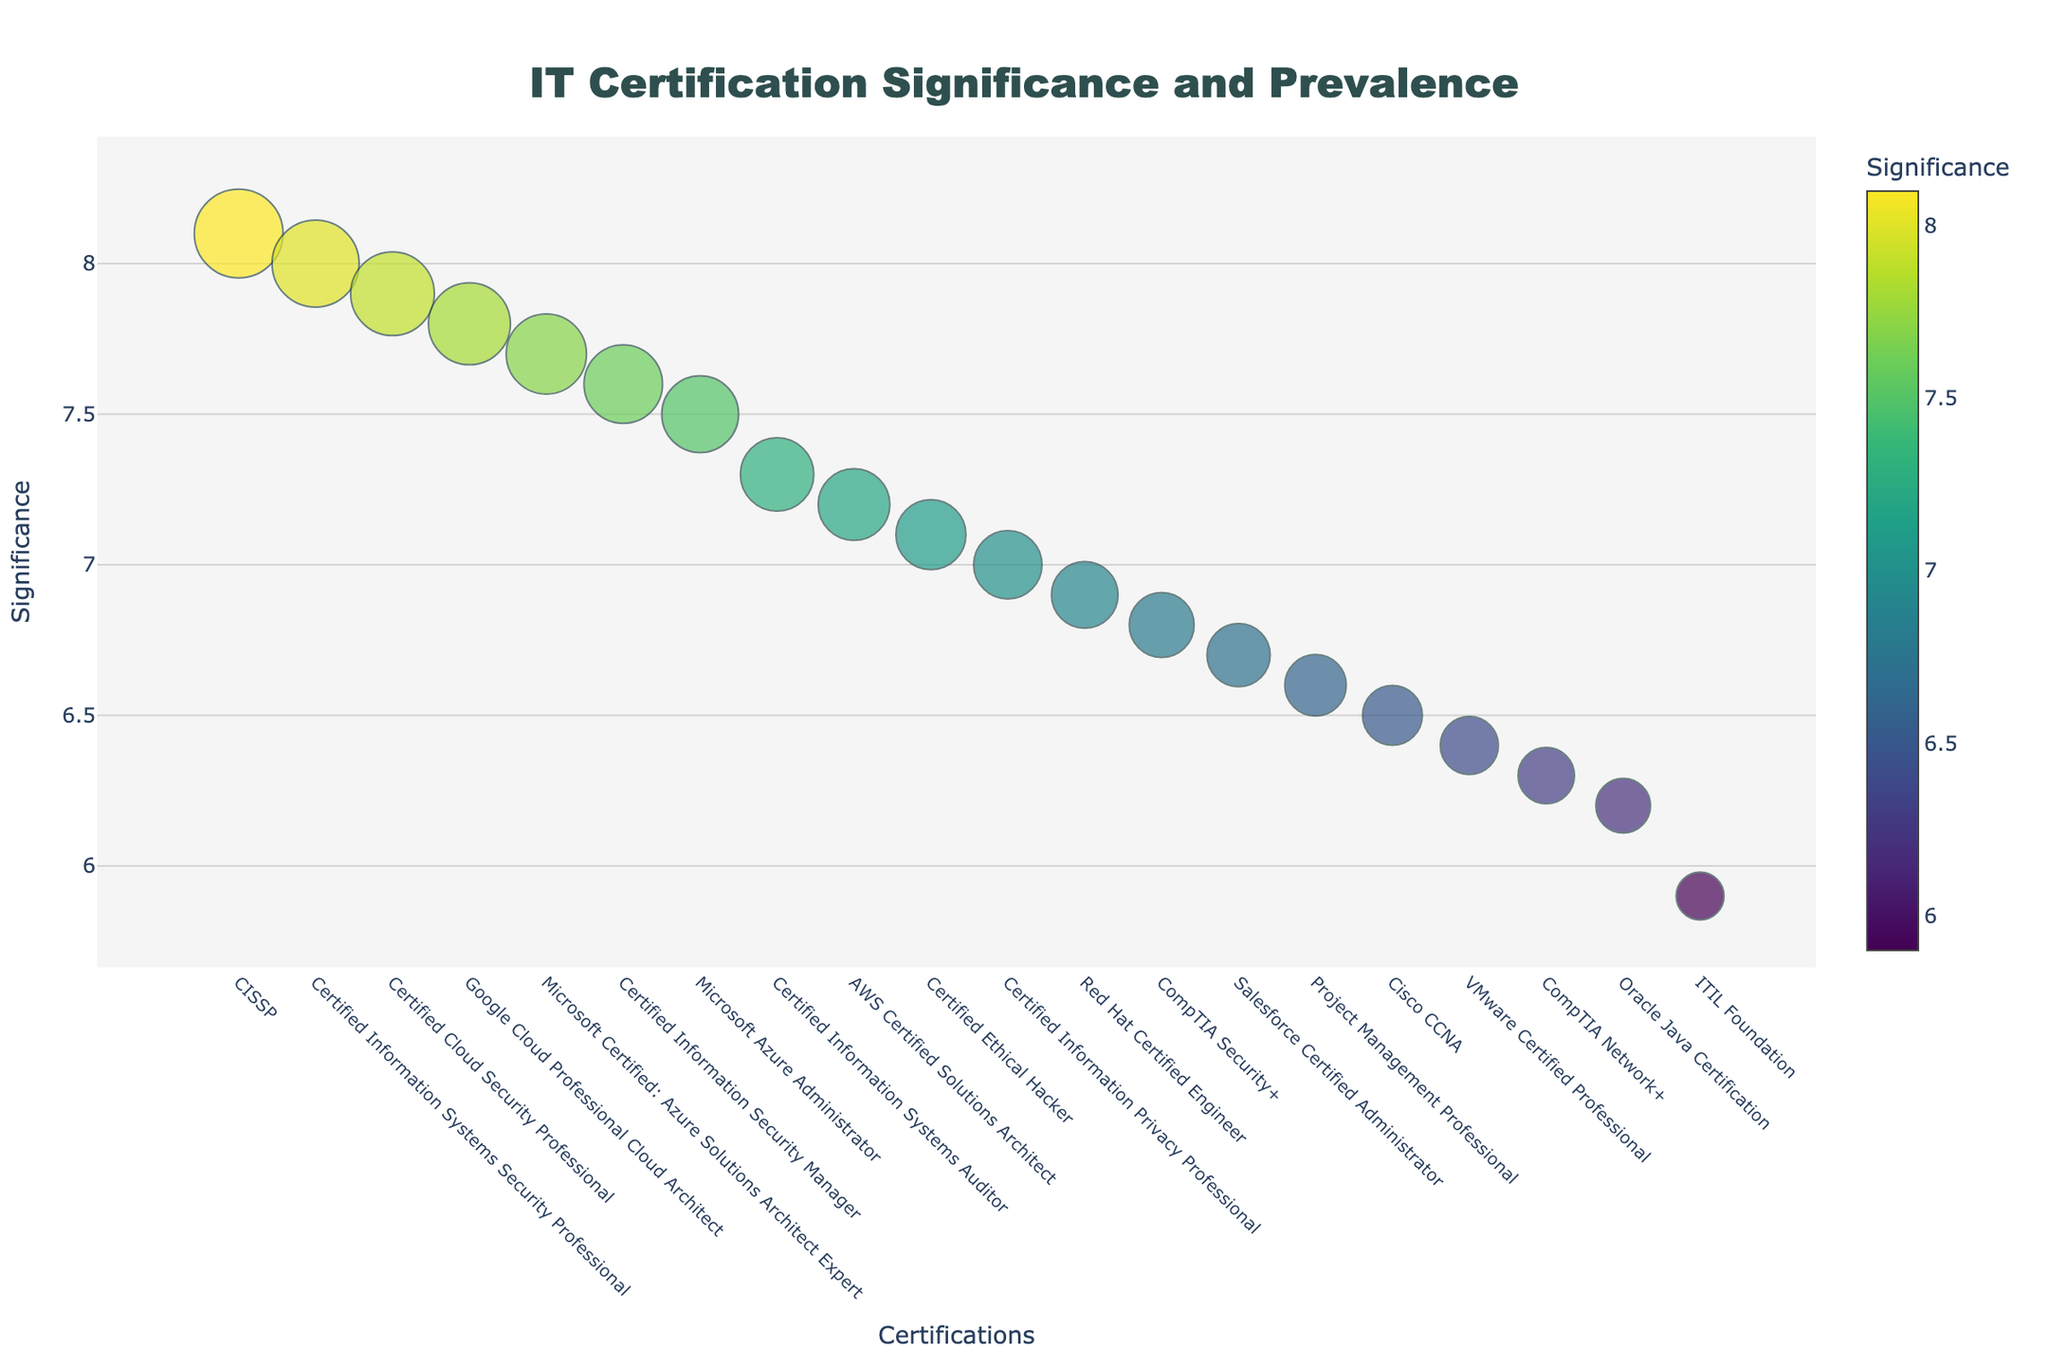What is the title of the figure? The title is usually placed at the top of the figure and is designed to summarize the main theme of the plot.
Answer: IT Certification Significance and Prevalence What certification has the highest significance value? To identify this, look for the data point that has the highest y-value on the plot.
Answer: CISSP Which certification has the largest marker size, and what does it represent? The marker size represents the prevalence of a certification. The larger marker size would indicate higher prevalence.
Answer: CISSP (52) How many certifications have a significance value greater than 7.5? Count the number of data points with y-values greater than 7.5 by visually inspecting the y-axis and the markers.
Answer: 5 Which certification is located at the far right of the x-axis? The certification at the far right position of the x-axis can be identified visually.
Answer: Certified Information Privacy Professional What is the average prevalence of certifications with significance values greater than 7? To find the average, sum the prevalence for all certifications with a significance value over 7 and divide by the number of these certifications.
Answer: (42 + 38 + 45 + 48 + 52 + 41 + 43 + 46 + 49 + 51 + 47 + 40) / 12 = 45 Compare the prevalence values of CISSP and Microsoft Azure Administrator. Which one is higher and by how much? Locate the markers representing both certifications. Subtract the prevalence value of Microsoft Azure Administrator from CISSP.
Answer: CISSP is higher by 52 - 45 = 7 What is the lowest significance value on the plot and which certification does it belong to? Identify the marker with the lowest y-value and read the corresponding certification from the x-axis.
Answer: ITIL Foundation (5.9) Which certification has a prevalence closest to 40 and what is its corresponding significance value? Identify the marker with the size closest to 40 and check its y-value.
Answer: Certified Information Privacy Professional (7.0) How does the Certified Ethical Hacker certification compare in significance and prevalence to the Google Cloud Professional Cloud Architect certification? Compare the y-values (significance) and the size of markers (prevalence) for both certifications.
Answer: Google Cloud Professional Cloud Architect has higher significance (7.8 vs 7.1) and higher prevalence (48 vs 41) 